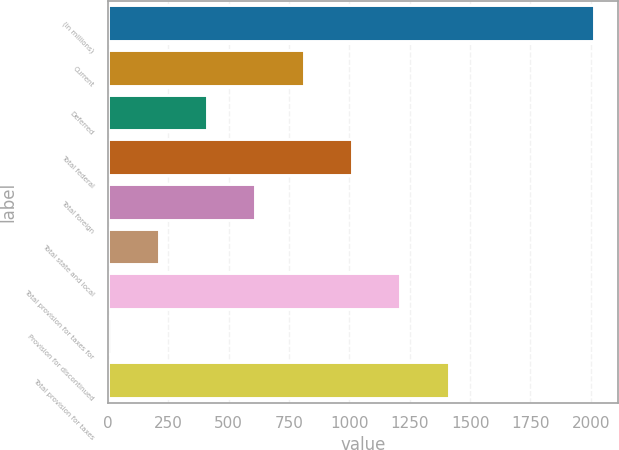<chart> <loc_0><loc_0><loc_500><loc_500><bar_chart><fcel>(in millions)<fcel>Current<fcel>Deferred<fcel>Total federal<fcel>Total foreign<fcel>Total state and local<fcel>Total provision for taxes for<fcel>Provision for discontinued<fcel>Total provision for taxes<nl><fcel>2012<fcel>811.4<fcel>411.2<fcel>1011.5<fcel>611.3<fcel>211.1<fcel>1211.6<fcel>11<fcel>1411.7<nl></chart> 